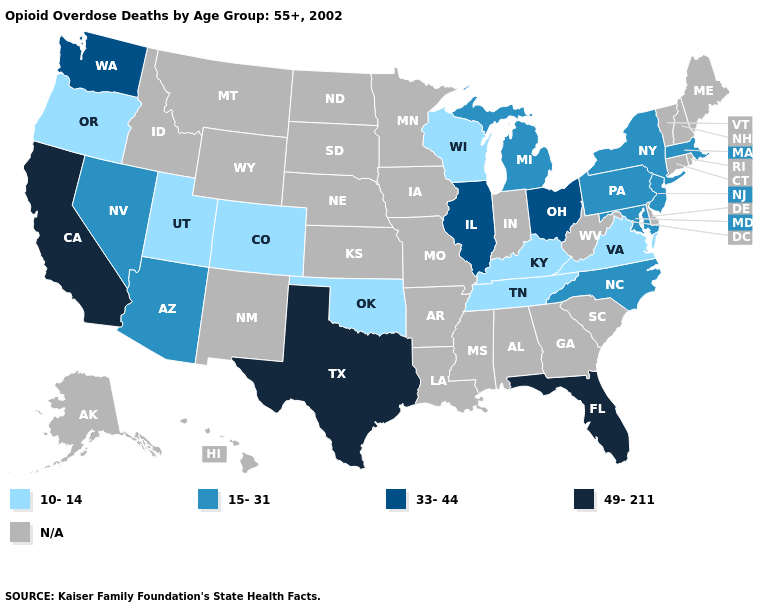What is the value of Illinois?
Concise answer only. 33-44. Name the states that have a value in the range 49-211?
Write a very short answer. California, Florida, Texas. Is the legend a continuous bar?
Be succinct. No. Name the states that have a value in the range N/A?
Short answer required. Alabama, Alaska, Arkansas, Connecticut, Delaware, Georgia, Hawaii, Idaho, Indiana, Iowa, Kansas, Louisiana, Maine, Minnesota, Mississippi, Missouri, Montana, Nebraska, New Hampshire, New Mexico, North Dakota, Rhode Island, South Carolina, South Dakota, Vermont, West Virginia, Wyoming. Name the states that have a value in the range N/A?
Concise answer only. Alabama, Alaska, Arkansas, Connecticut, Delaware, Georgia, Hawaii, Idaho, Indiana, Iowa, Kansas, Louisiana, Maine, Minnesota, Mississippi, Missouri, Montana, Nebraska, New Hampshire, New Mexico, North Dakota, Rhode Island, South Carolina, South Dakota, Vermont, West Virginia, Wyoming. Name the states that have a value in the range 33-44?
Be succinct. Illinois, Ohio, Washington. What is the highest value in the South ?
Concise answer only. 49-211. Does California have the highest value in the USA?
Be succinct. Yes. Among the states that border Georgia , does Tennessee have the highest value?
Concise answer only. No. Is the legend a continuous bar?
Write a very short answer. No. Name the states that have a value in the range 15-31?
Write a very short answer. Arizona, Maryland, Massachusetts, Michigan, Nevada, New Jersey, New York, North Carolina, Pennsylvania. Name the states that have a value in the range N/A?
Short answer required. Alabama, Alaska, Arkansas, Connecticut, Delaware, Georgia, Hawaii, Idaho, Indiana, Iowa, Kansas, Louisiana, Maine, Minnesota, Mississippi, Missouri, Montana, Nebraska, New Hampshire, New Mexico, North Dakota, Rhode Island, South Carolina, South Dakota, Vermont, West Virginia, Wyoming. Among the states that border Connecticut , which have the lowest value?
Be succinct. Massachusetts, New York. Name the states that have a value in the range 49-211?
Write a very short answer. California, Florida, Texas. 